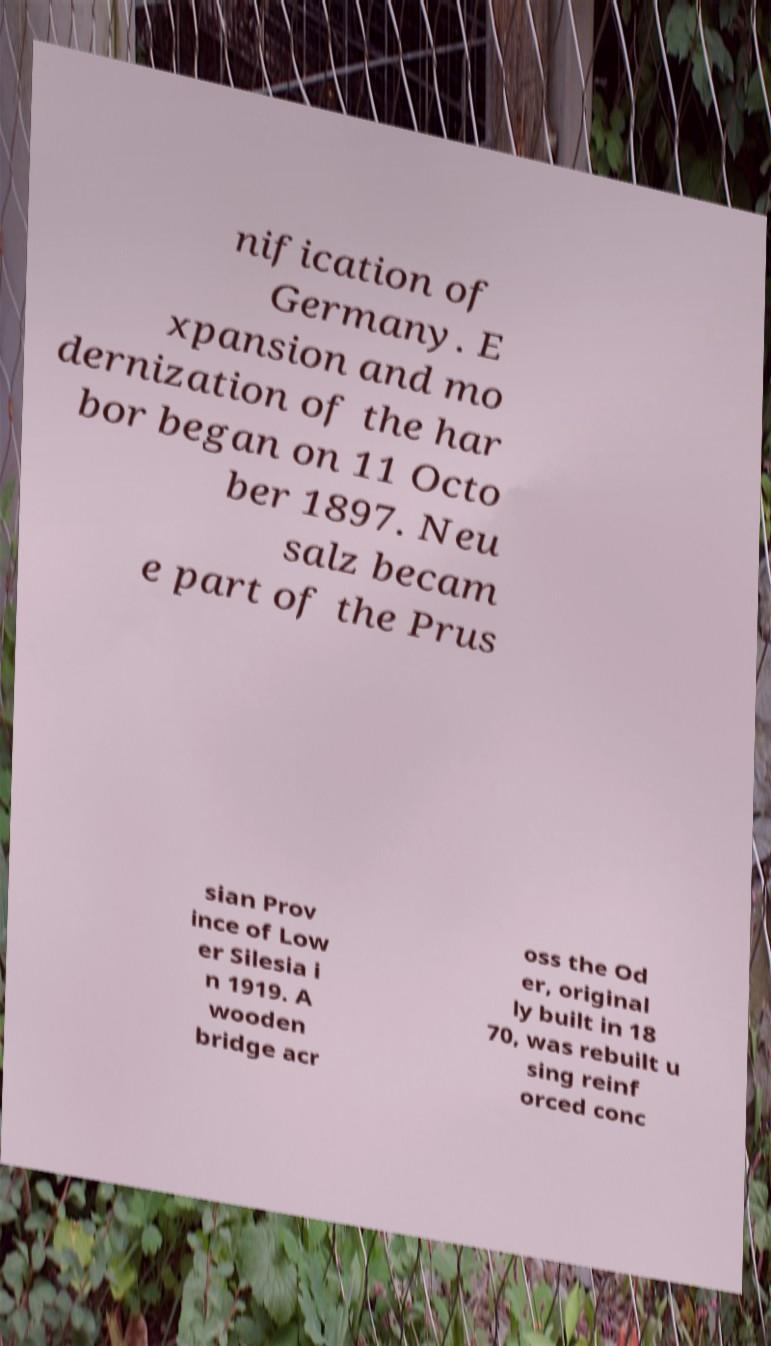For documentation purposes, I need the text within this image transcribed. Could you provide that? nification of Germany. E xpansion and mo dernization of the har bor began on 11 Octo ber 1897. Neu salz becam e part of the Prus sian Prov ince of Low er Silesia i n 1919. A wooden bridge acr oss the Od er, original ly built in 18 70, was rebuilt u sing reinf orced conc 